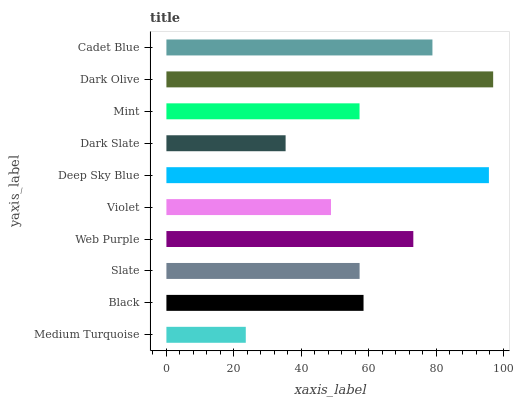Is Medium Turquoise the minimum?
Answer yes or no. Yes. Is Dark Olive the maximum?
Answer yes or no. Yes. Is Black the minimum?
Answer yes or no. No. Is Black the maximum?
Answer yes or no. No. Is Black greater than Medium Turquoise?
Answer yes or no. Yes. Is Medium Turquoise less than Black?
Answer yes or no. Yes. Is Medium Turquoise greater than Black?
Answer yes or no. No. Is Black less than Medium Turquoise?
Answer yes or no. No. Is Black the high median?
Answer yes or no. Yes. Is Slate the low median?
Answer yes or no. Yes. Is Slate the high median?
Answer yes or no. No. Is Violet the low median?
Answer yes or no. No. 